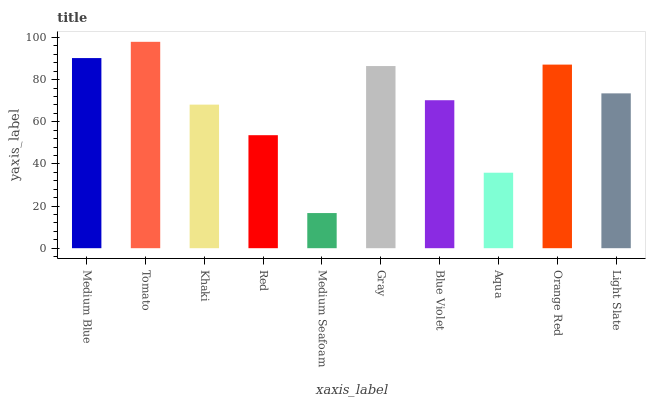Is Medium Seafoam the minimum?
Answer yes or no. Yes. Is Tomato the maximum?
Answer yes or no. Yes. Is Khaki the minimum?
Answer yes or no. No. Is Khaki the maximum?
Answer yes or no. No. Is Tomato greater than Khaki?
Answer yes or no. Yes. Is Khaki less than Tomato?
Answer yes or no. Yes. Is Khaki greater than Tomato?
Answer yes or no. No. Is Tomato less than Khaki?
Answer yes or no. No. Is Light Slate the high median?
Answer yes or no. Yes. Is Blue Violet the low median?
Answer yes or no. Yes. Is Medium Blue the high median?
Answer yes or no. No. Is Khaki the low median?
Answer yes or no. No. 